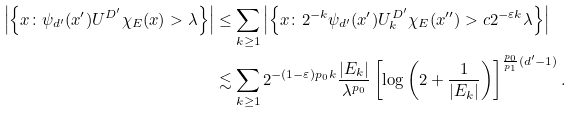<formula> <loc_0><loc_0><loc_500><loc_500>\left | \left \{ x \colon \psi _ { d ^ { \prime } } ( x ^ { \prime } ) U ^ { D ^ { \prime } } \chi _ { E } ( x ) > \lambda \right \} \right | & \leq \sum _ { k \geq 1 } \left | \left \{ x \colon 2 ^ { - k } \psi _ { d ^ { \prime } } ( x ^ { \prime } ) U ^ { D ^ { \prime } } _ { k } \chi _ { E } ( x ^ { \prime \prime } ) > c 2 ^ { - \varepsilon k } \lambda \right \} \right | \\ & \lesssim \sum _ { k \geq 1 } 2 ^ { - ( 1 - \varepsilon ) p _ { 0 } k } \frac { | E _ { k } | } { \lambda ^ { p _ { 0 } } } \left [ \log \left ( 2 + \frac { 1 } { | E _ { k } | } \right ) \right ] ^ { \frac { p _ { 0 } } { p _ { 1 } } ( d ^ { \prime } - 1 ) } .</formula> 